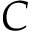<formula> <loc_0><loc_0><loc_500><loc_500>C</formula> 